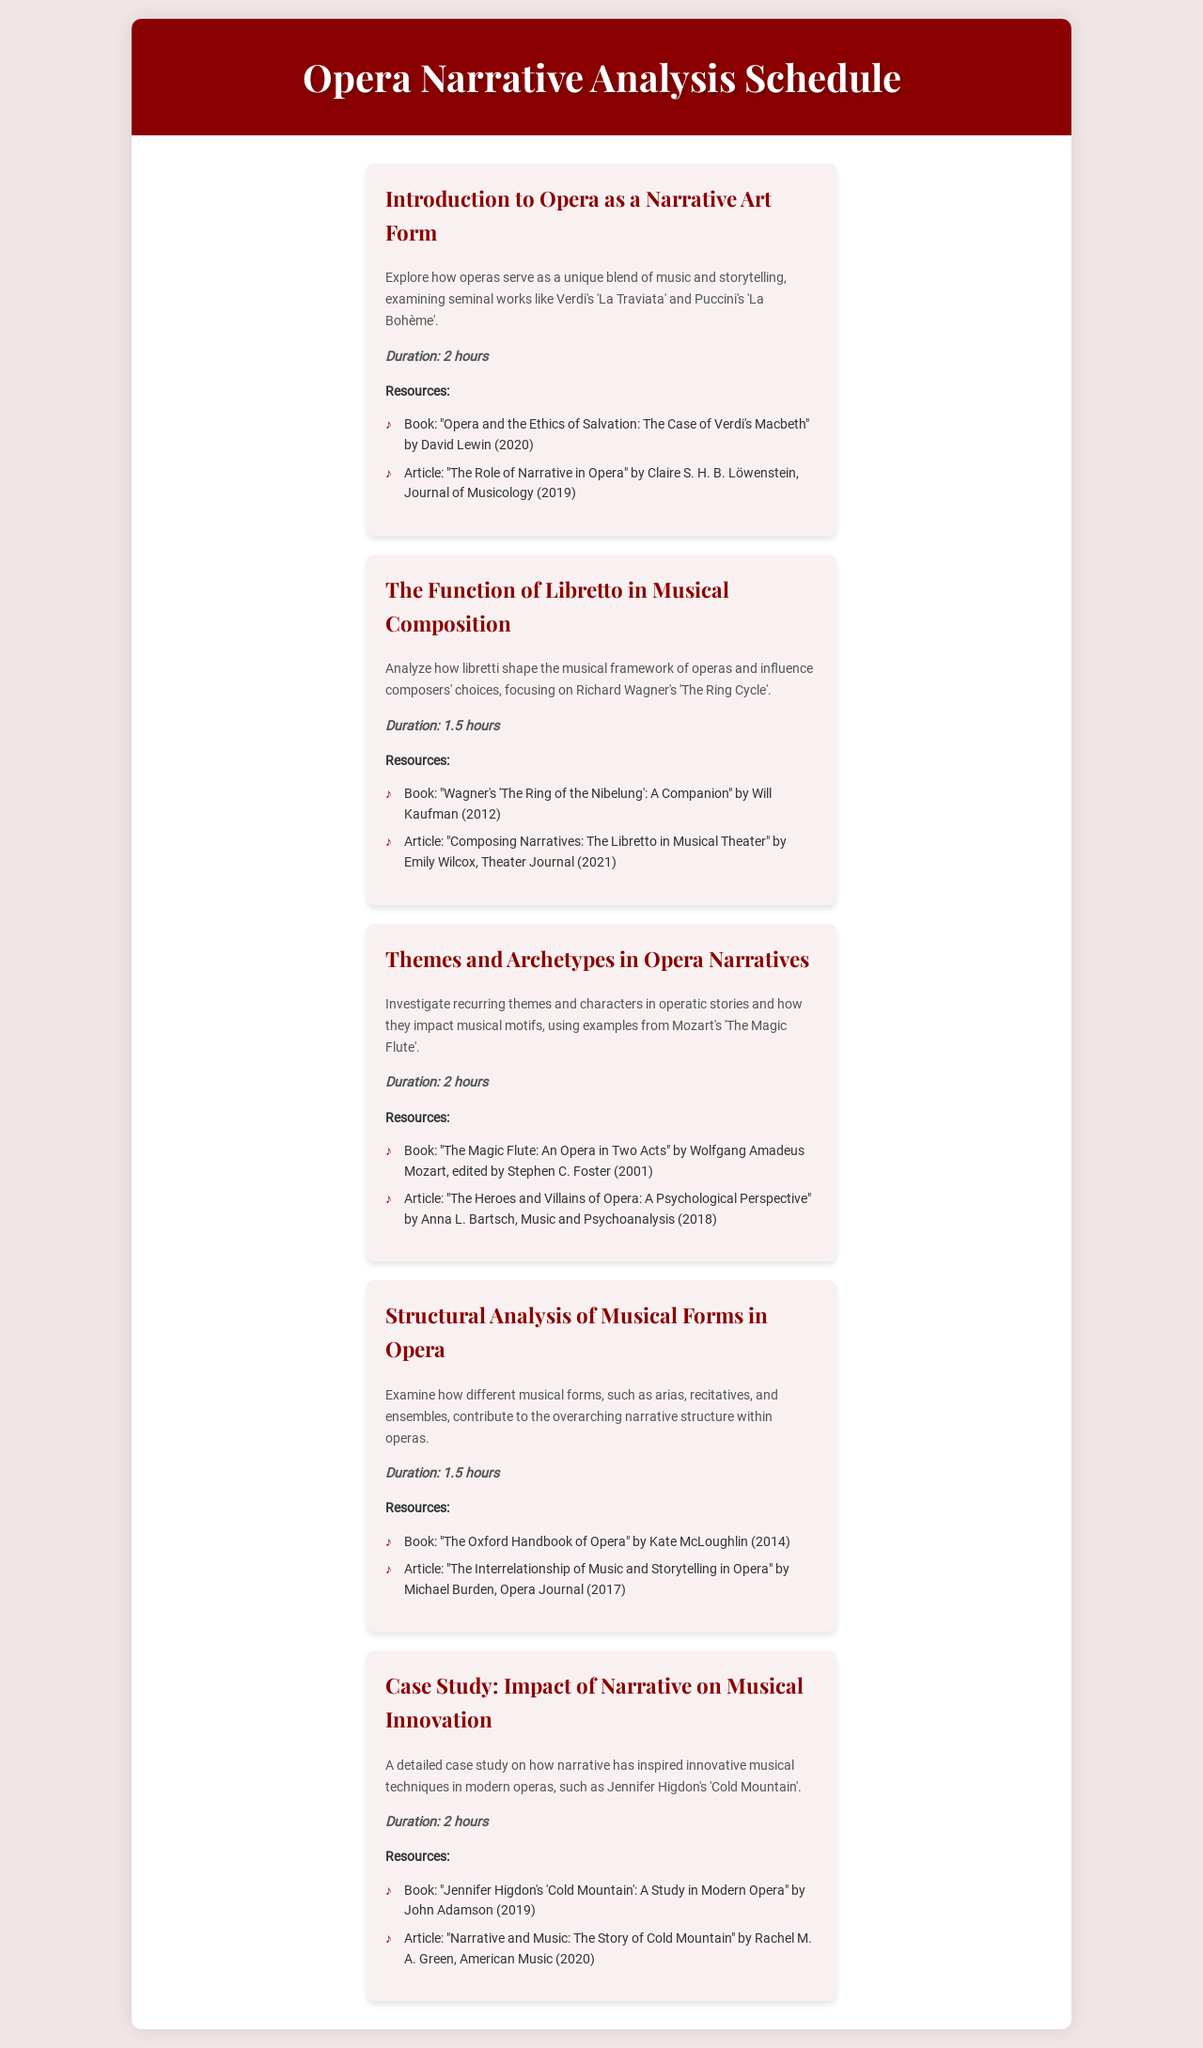What is the duration of the first session? The duration of the first session, "Introduction to Opera as a Narrative Art Form," is stated as 2 hours in the document.
Answer: 2 hours Which composer is focused on in the second session? The second session, "The Function of Libretto in Musical Composition," focuses on Richard Wagner, as mentioned in the session description.
Answer: Richard Wagner How many sessions are there in total? The document lists five distinct sessions covering various topics related to opera narrative analysis.
Answer: Five What is the title of the book referenced in the third session? The book mentioned in the resources for the third session is "The Magic Flute: An Opera in Two Acts" by Wolfgang Amadeus Mozart.
Answer: The Magic Flute: An Opera in Two Acts What is the main focus of the fourth session? The fourth session, "Structural Analysis of Musical Forms in Opera," is focused on examining different musical forms like arias and recitatives in relation to narrative structure.
Answer: Different musical forms What is being compared in the fifth session's case study? The fifth session presents a case study comparing narrative inspiration and musical techniques, specifically in modern operas such as Jennifer Higdon's "Cold Mountain."
Answer: Narrative and musical techniques Which article discusses the interrelationship of music and storytelling? The article "The Interrelationship of Music and Storytelling in Opera" by Michael Burden is mentioned in the resources of the fourth session.
Answer: The Interrelationship of Music and Storytelling in Opera What narrative theme is highlighted in the third session? The third session investigates recurring themes and characters in operatic stories which are reflected in musical motifs.
Answer: Recurring themes and characters 